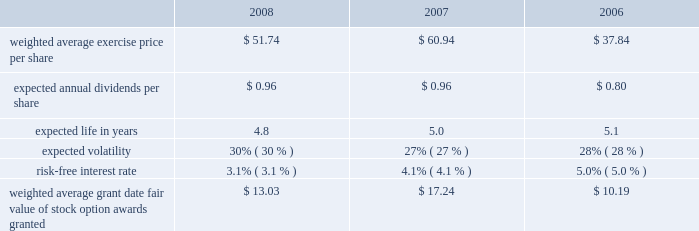Marathon oil corporation notes to consolidated financial statements stock appreciation rights 2013 prior to 2005 , we granted sars under the 2003 plan .
No stock appreciation rights have been granted under the 2007 plan .
Similar to stock options , stock appreciation rights represent the right to receive a payment equal to the excess of the fair market value of shares of common stock on the date the right is exercised over the grant price .
Under the 2003 plan , certain sars were granted as stock-settled sars and others were granted in tandem with stock options .
In general , sars granted under the 2003 plan vest ratably over a three-year period and have a maximum term of ten years from the date they are granted .
Stock-based performance awards 2013 prior to 2005 , we granted stock-based performance awards under the 2003 plan .
No stock-based performance awards have been granted under the 2007 plan .
Beginning in 2005 , we discontinued granting stock-based performance awards and instead now grant cash-settled performance units to officers .
All stock-based performance awards granted under the 2003 plan have either vested or been forfeited .
As a result , there are no outstanding stock-based performance awards .
Restricted stock 2013 we grant restricted stock and restricted stock units under the 2007 plan and previously granted such awards under the 2003 plan .
In 2005 , the compensation committee began granting time-based restricted stock to certain u.s.-based officers of marathon and its consolidated subsidiaries as part of their annual long-term incentive package .
The restricted stock awards to officers vest three years from the date of grant , contingent on the recipient 2019s continued employment .
We also grant restricted stock to certain non-officer employees and restricted stock units to certain international employees ( 201crestricted stock awards 201d ) , based on their performance within certain guidelines and for retention purposes .
The restricted stock awards to non-officers generally vest in one-third increments over a three-year period , contingent on the recipient 2019s continued employment , however , certain restricted stock awards granted in 2008 will vest over a four-year period , contingent on the recipient 2019s continued employment .
Prior to vesting , all restricted stock recipients have the right to vote such stock and receive dividends thereon .
The non-vested shares are not transferable and are held by our transfer agent .
Common stock units 2013 we maintain an equity compensation program for our non-employee directors under the 2007 plan and previously maintained such a program under the 2003 plan .
All non-employee directors other than the chairman receive annual grants of common stock units , and they are required to hold those units until they leave the board of directors .
When dividends are paid on marathon common stock , directors receive dividend equivalents in the form of additional common stock units .
Total stock-based compensation expense total employee stock-based compensation expense was $ 43 million , $ 66 million and $ 78 million in 2008 , 2007 and 2006 .
The total related income tax benefits were $ 16 million , $ 24 million and $ 29 million .
In 2008 and 2007 , cash received upon exercise of stock option awards was $ 9 million and $ 27 million .
Tax benefits realized for deductions during 2008 and 2007 that were in excess of the stock-based compensation expense recorded for options exercised and other stock-based awards vested during the period totaled $ 7 million and $ 30 million .
Cash settlements of stock option awards totaled $ 1 million in 2007 .
There were no cash settlements in 2008 .
Stock option awards during 2008 , 2007 and 2006 , we granted stock option awards to both officer and non-officer employees .
The weighted average grant date fair value of these awards was based on the following black-scholes assumptions: .

By what percentage did the company's weighted average exercise price per share increase from 2006 to 2008? 
Computations: ((51.74 - 37.84) / 37.84)
Answer: 0.36734. 